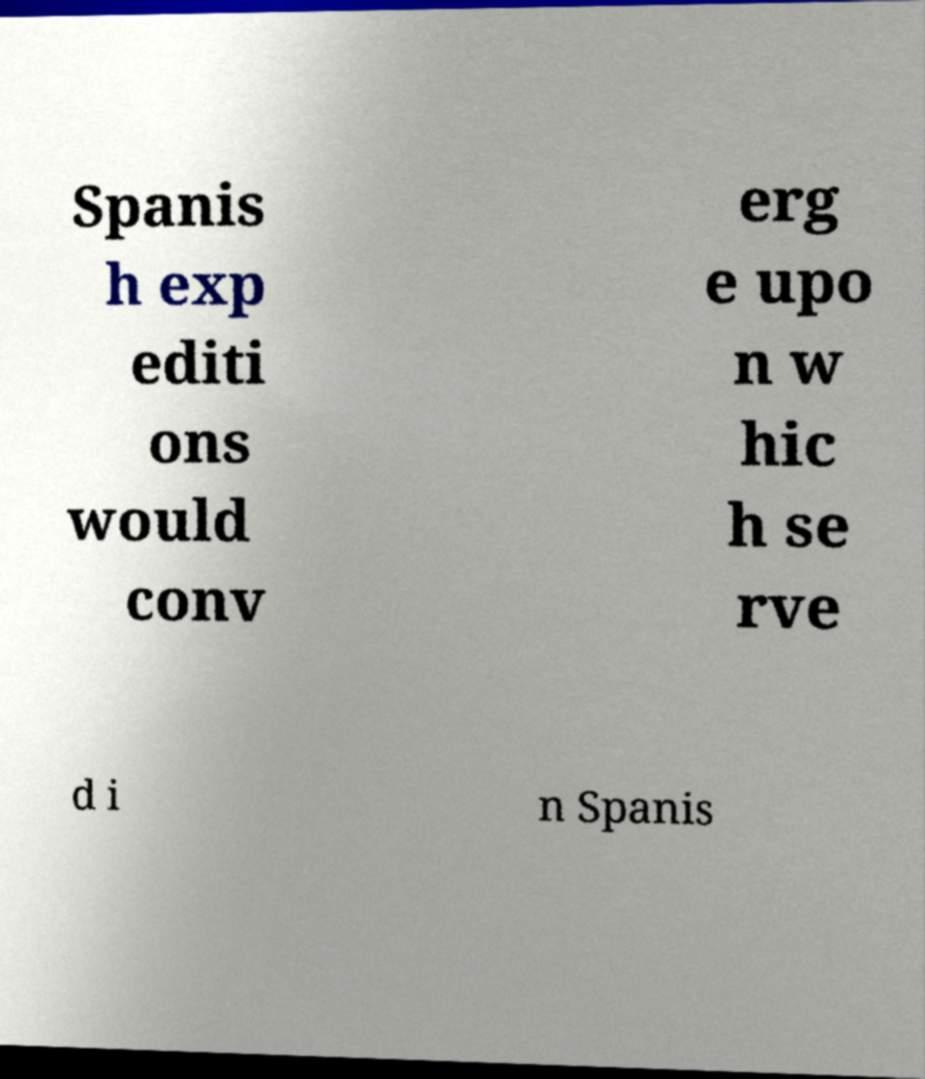Can you read and provide the text displayed in the image?This photo seems to have some interesting text. Can you extract and type it out for me? Spanis h exp editi ons would conv erg e upo n w hic h se rve d i n Spanis 